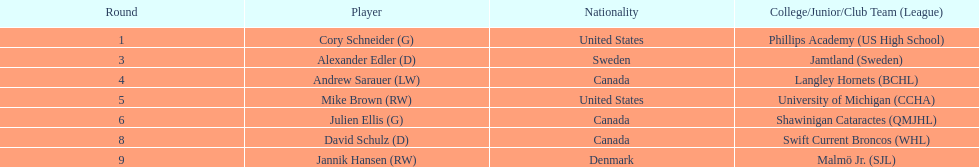How many players are from the united states? 2. 